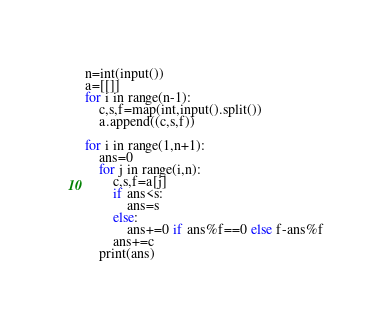<code> <loc_0><loc_0><loc_500><loc_500><_Python_>n=int(input())
a=[[]]
for i in range(n-1):
    c,s,f=map(int,input().split())
    a.append((c,s,f))

for i in range(1,n+1):
    ans=0
    for j in range(i,n):
        c,s,f=a[j]
        if ans<s:
            ans=s
        else:
            ans+=0 if ans%f==0 else f-ans%f
        ans+=c
    print(ans)</code> 